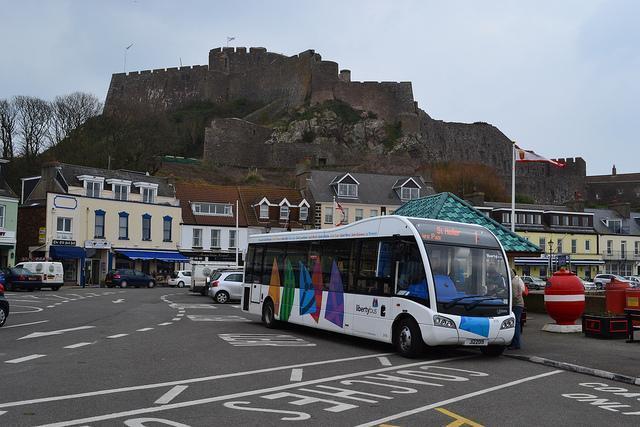How many people are between the two orange buses in the image?
Give a very brief answer. 0. 